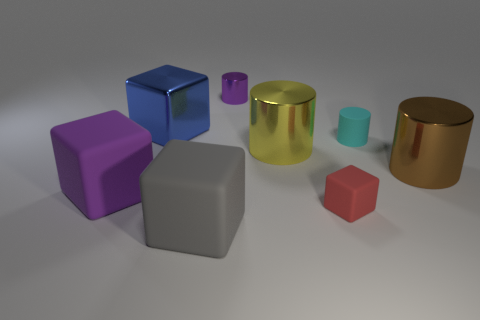What number of other things are there of the same size as the red object?
Your answer should be very brief. 2. How many things are either tiny red things or metal objects that are on the right side of the gray rubber block?
Keep it short and to the point. 4. Are there fewer large purple matte cylinders than purple metal things?
Offer a terse response. Yes. There is a tiny cylinder that is on the right side of the cylinder that is behind the big blue thing; what is its color?
Ensure brevity in your answer.  Cyan. There is a brown thing that is the same shape as the big yellow shiny thing; what is it made of?
Provide a succinct answer. Metal. How many matte things are either big purple blocks or big brown cylinders?
Offer a very short reply. 1. Is the material of the purple thing to the left of the gray rubber block the same as the tiny cylinder on the right side of the tiny purple cylinder?
Make the answer very short. Yes. Are there any red matte balls?
Keep it short and to the point. No. Does the tiny rubber thing that is in front of the brown metallic thing have the same shape as the small rubber thing that is behind the brown cylinder?
Your response must be concise. No. Are there any yellow objects made of the same material as the brown object?
Your answer should be compact. Yes. 